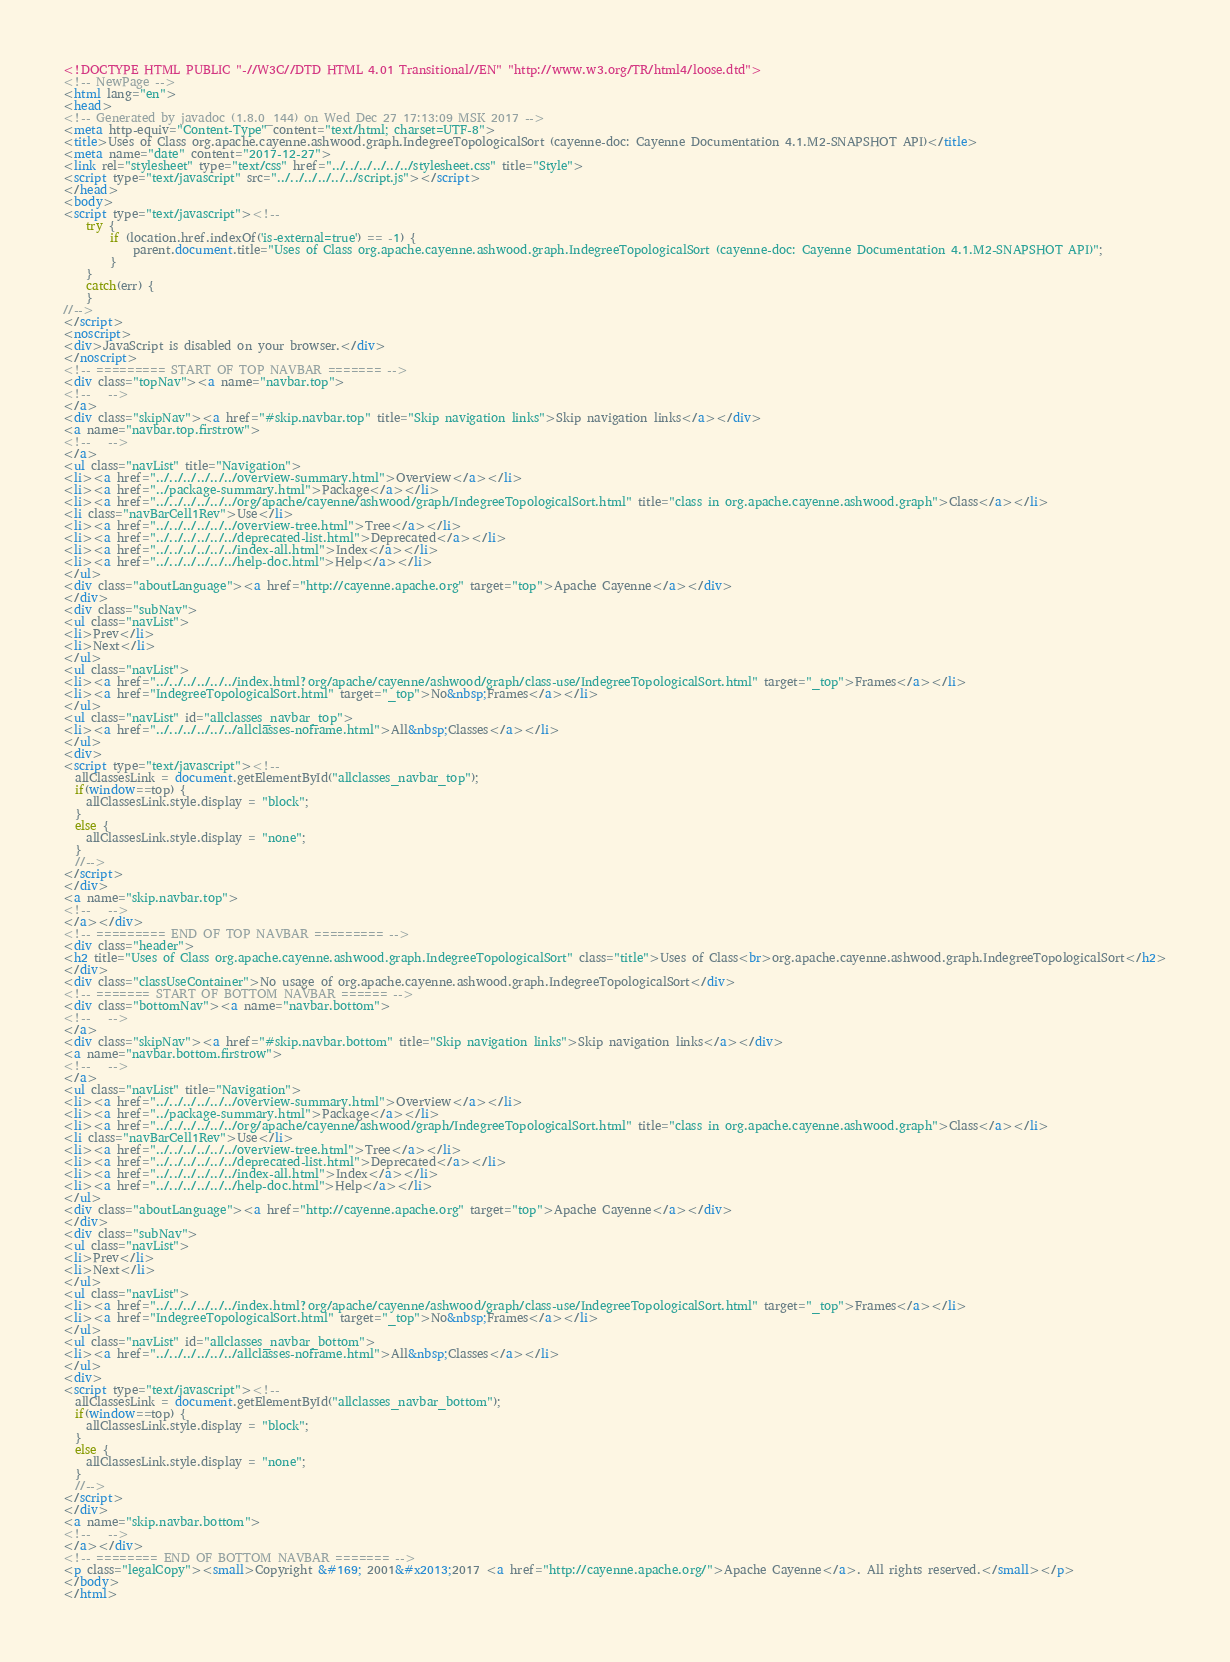Convert code to text. <code><loc_0><loc_0><loc_500><loc_500><_HTML_><!DOCTYPE HTML PUBLIC "-//W3C//DTD HTML 4.01 Transitional//EN" "http://www.w3.org/TR/html4/loose.dtd">
<!-- NewPage -->
<html lang="en">
<head>
<!-- Generated by javadoc (1.8.0_144) on Wed Dec 27 17:13:09 MSK 2017 -->
<meta http-equiv="Content-Type" content="text/html; charset=UTF-8">
<title>Uses of Class org.apache.cayenne.ashwood.graph.IndegreeTopologicalSort (cayenne-doc: Cayenne Documentation 4.1.M2-SNAPSHOT API)</title>
<meta name="date" content="2017-12-27">
<link rel="stylesheet" type="text/css" href="../../../../../../stylesheet.css" title="Style">
<script type="text/javascript" src="../../../../../../script.js"></script>
</head>
<body>
<script type="text/javascript"><!--
    try {
        if (location.href.indexOf('is-external=true') == -1) {
            parent.document.title="Uses of Class org.apache.cayenne.ashwood.graph.IndegreeTopologicalSort (cayenne-doc: Cayenne Documentation 4.1.M2-SNAPSHOT API)";
        }
    }
    catch(err) {
    }
//-->
</script>
<noscript>
<div>JavaScript is disabled on your browser.</div>
</noscript>
<!-- ========= START OF TOP NAVBAR ======= -->
<div class="topNav"><a name="navbar.top">
<!--   -->
</a>
<div class="skipNav"><a href="#skip.navbar.top" title="Skip navigation links">Skip navigation links</a></div>
<a name="navbar.top.firstrow">
<!--   -->
</a>
<ul class="navList" title="Navigation">
<li><a href="../../../../../../overview-summary.html">Overview</a></li>
<li><a href="../package-summary.html">Package</a></li>
<li><a href="../../../../../../org/apache/cayenne/ashwood/graph/IndegreeTopologicalSort.html" title="class in org.apache.cayenne.ashwood.graph">Class</a></li>
<li class="navBarCell1Rev">Use</li>
<li><a href="../../../../../../overview-tree.html">Tree</a></li>
<li><a href="../../../../../../deprecated-list.html">Deprecated</a></li>
<li><a href="../../../../../../index-all.html">Index</a></li>
<li><a href="../../../../../../help-doc.html">Help</a></li>
</ul>
<div class="aboutLanguage"><a href="http://cayenne.apache.org" target="top">Apache Cayenne</a></div>
</div>
<div class="subNav">
<ul class="navList">
<li>Prev</li>
<li>Next</li>
</ul>
<ul class="navList">
<li><a href="../../../../../../index.html?org/apache/cayenne/ashwood/graph/class-use/IndegreeTopologicalSort.html" target="_top">Frames</a></li>
<li><a href="IndegreeTopologicalSort.html" target="_top">No&nbsp;Frames</a></li>
</ul>
<ul class="navList" id="allclasses_navbar_top">
<li><a href="../../../../../../allclasses-noframe.html">All&nbsp;Classes</a></li>
</ul>
<div>
<script type="text/javascript"><!--
  allClassesLink = document.getElementById("allclasses_navbar_top");
  if(window==top) {
    allClassesLink.style.display = "block";
  }
  else {
    allClassesLink.style.display = "none";
  }
  //-->
</script>
</div>
<a name="skip.navbar.top">
<!--   -->
</a></div>
<!-- ========= END OF TOP NAVBAR ========= -->
<div class="header">
<h2 title="Uses of Class org.apache.cayenne.ashwood.graph.IndegreeTopologicalSort" class="title">Uses of Class<br>org.apache.cayenne.ashwood.graph.IndegreeTopologicalSort</h2>
</div>
<div class="classUseContainer">No usage of org.apache.cayenne.ashwood.graph.IndegreeTopologicalSort</div>
<!-- ======= START OF BOTTOM NAVBAR ====== -->
<div class="bottomNav"><a name="navbar.bottom">
<!--   -->
</a>
<div class="skipNav"><a href="#skip.navbar.bottom" title="Skip navigation links">Skip navigation links</a></div>
<a name="navbar.bottom.firstrow">
<!--   -->
</a>
<ul class="navList" title="Navigation">
<li><a href="../../../../../../overview-summary.html">Overview</a></li>
<li><a href="../package-summary.html">Package</a></li>
<li><a href="../../../../../../org/apache/cayenne/ashwood/graph/IndegreeTopologicalSort.html" title="class in org.apache.cayenne.ashwood.graph">Class</a></li>
<li class="navBarCell1Rev">Use</li>
<li><a href="../../../../../../overview-tree.html">Tree</a></li>
<li><a href="../../../../../../deprecated-list.html">Deprecated</a></li>
<li><a href="../../../../../../index-all.html">Index</a></li>
<li><a href="../../../../../../help-doc.html">Help</a></li>
</ul>
<div class="aboutLanguage"><a href="http://cayenne.apache.org" target="top">Apache Cayenne</a></div>
</div>
<div class="subNav">
<ul class="navList">
<li>Prev</li>
<li>Next</li>
</ul>
<ul class="navList">
<li><a href="../../../../../../index.html?org/apache/cayenne/ashwood/graph/class-use/IndegreeTopologicalSort.html" target="_top">Frames</a></li>
<li><a href="IndegreeTopologicalSort.html" target="_top">No&nbsp;Frames</a></li>
</ul>
<ul class="navList" id="allclasses_navbar_bottom">
<li><a href="../../../../../../allclasses-noframe.html">All&nbsp;Classes</a></li>
</ul>
<div>
<script type="text/javascript"><!--
  allClassesLink = document.getElementById("allclasses_navbar_bottom");
  if(window==top) {
    allClassesLink.style.display = "block";
  }
  else {
    allClassesLink.style.display = "none";
  }
  //-->
</script>
</div>
<a name="skip.navbar.bottom">
<!--   -->
</a></div>
<!-- ======== END OF BOTTOM NAVBAR ======= -->
<p class="legalCopy"><small>Copyright &#169; 2001&#x2013;2017 <a href="http://cayenne.apache.org/">Apache Cayenne</a>. All rights reserved.</small></p>
</body>
</html>
</code> 